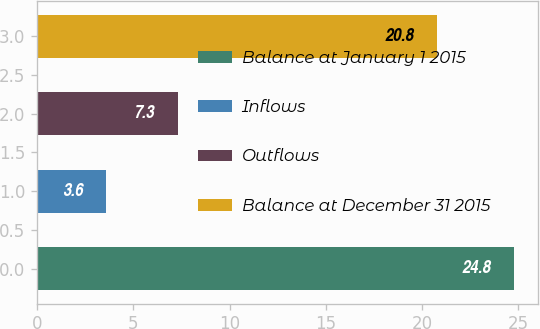<chart> <loc_0><loc_0><loc_500><loc_500><bar_chart><fcel>Balance at January 1 2015<fcel>Inflows<fcel>Outflows<fcel>Balance at December 31 2015<nl><fcel>24.8<fcel>3.6<fcel>7.3<fcel>20.8<nl></chart> 